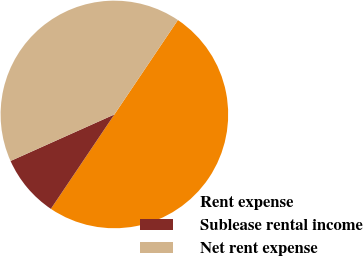Convert chart to OTSL. <chart><loc_0><loc_0><loc_500><loc_500><pie_chart><fcel>Rent expense<fcel>Sublease rental income<fcel>Net rent expense<nl><fcel>50.0%<fcel>8.87%<fcel>41.13%<nl></chart> 